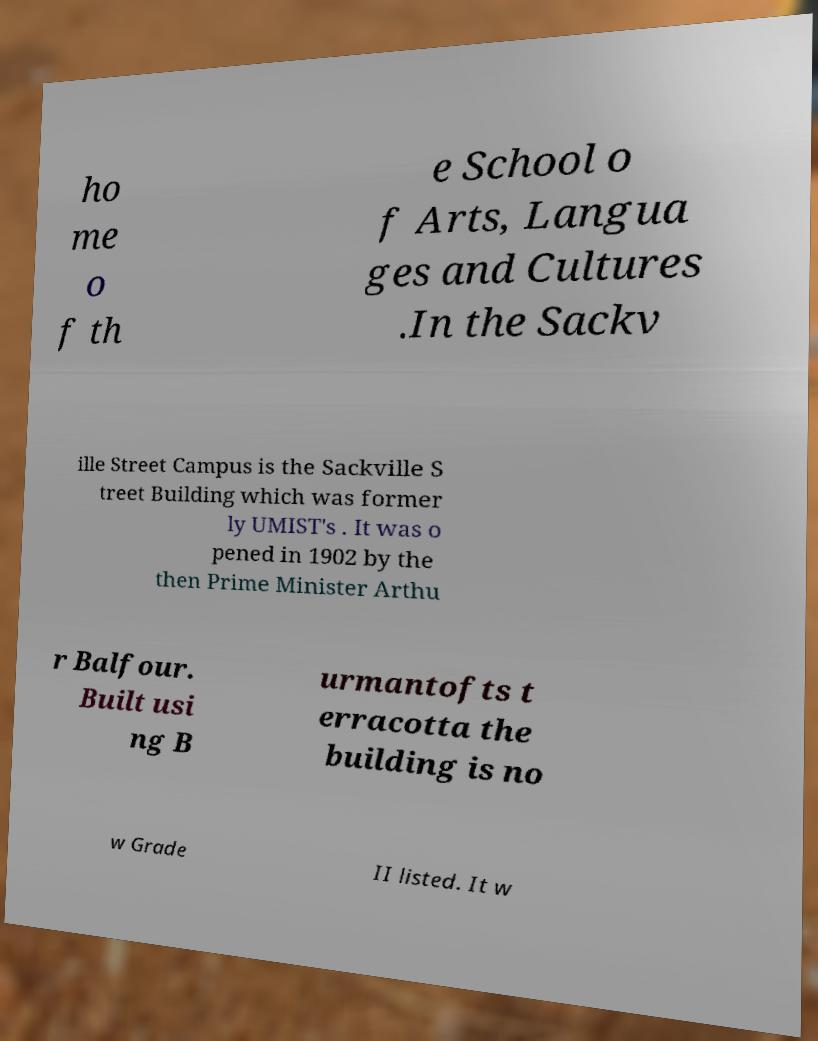Could you assist in decoding the text presented in this image and type it out clearly? ho me o f th e School o f Arts, Langua ges and Cultures .In the Sackv ille Street Campus is the Sackville S treet Building which was former ly UMIST's . It was o pened in 1902 by the then Prime Minister Arthu r Balfour. Built usi ng B urmantofts t erracotta the building is no w Grade II listed. It w 